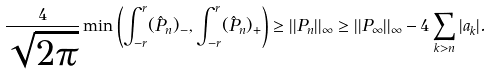<formula> <loc_0><loc_0><loc_500><loc_500>\frac { 4 } { \sqrt { 2 \pi } } \min \left ( \int _ { - r } ^ { r } ( \hat { P } _ { n } ) _ { - } , \int _ { - r } ^ { r } ( \hat { P } _ { n } ) _ { + } \right ) \geq | | P _ { n } | | _ { \infty } \geq | | P _ { \infty } | | _ { \infty } - 4 \sum _ { k > n } | a _ { k } | .</formula> 